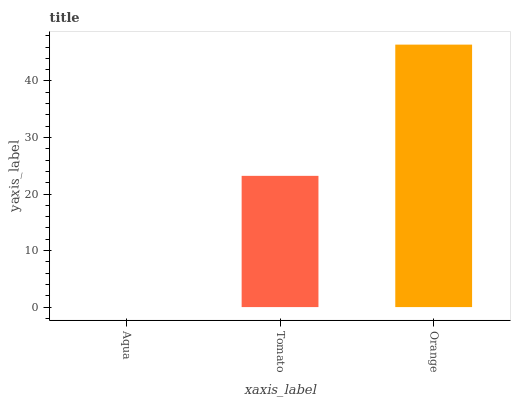Is Aqua the minimum?
Answer yes or no. Yes. Is Orange the maximum?
Answer yes or no. Yes. Is Tomato the minimum?
Answer yes or no. No. Is Tomato the maximum?
Answer yes or no. No. Is Tomato greater than Aqua?
Answer yes or no. Yes. Is Aqua less than Tomato?
Answer yes or no. Yes. Is Aqua greater than Tomato?
Answer yes or no. No. Is Tomato less than Aqua?
Answer yes or no. No. Is Tomato the high median?
Answer yes or no. Yes. Is Tomato the low median?
Answer yes or no. Yes. Is Orange the high median?
Answer yes or no. No. Is Aqua the low median?
Answer yes or no. No. 